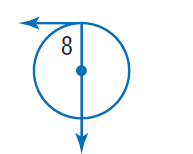Question: Find \angle 8.
Choices:
A. 20
B. 70
C. 90
D. 180
Answer with the letter. Answer: C 